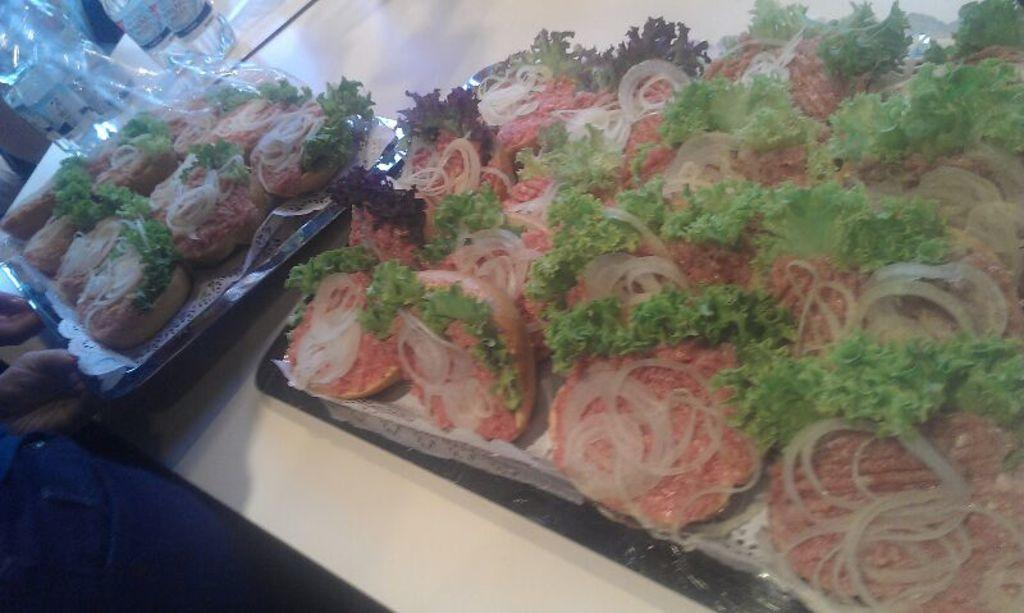What is the main subject on the table in the image? There are planets on a table in the image. What else can be seen on the table besides the planets? There is food on the table in the image. Where are the bottles located in the image? The bottles are in the top left of the image. What type of pan is being used to cook the planets in the image? There is no pan or cooking activity present in the image; it features planets on a table with food and bottles. 